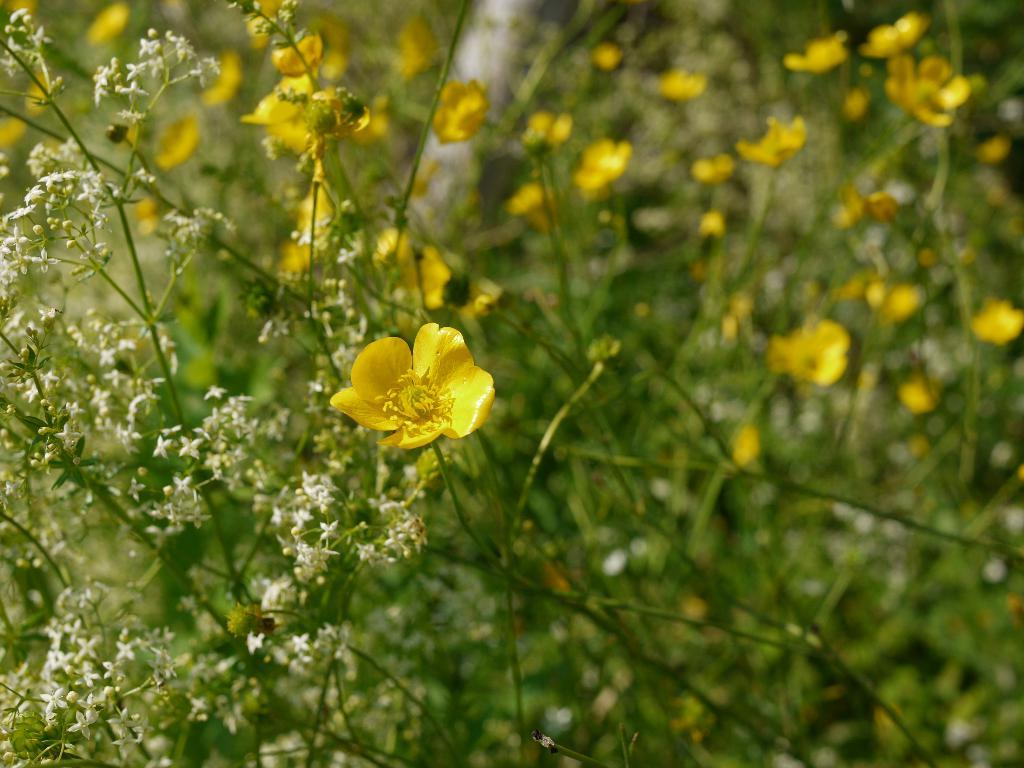What type of plants can be seen in the image? There are plants with flowers in the image. Can you describe the background of the image? The background of the image is blurry. What type of milk can be seen in the image? There is no milk present in the image. Can you hear any horns in the image? There is no sound or reference to a horn in the image. 